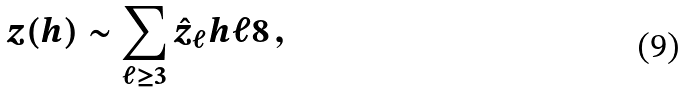<formula> <loc_0><loc_0><loc_500><loc_500>z ( h ) \sim \sum _ { \ell \geq 3 } \hat { z } _ { \ell } h ^ { } { \ell } 8 \, ,</formula> 